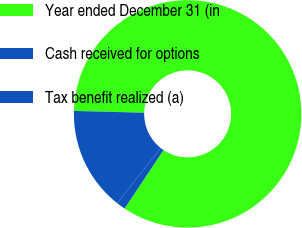<chart> <loc_0><loc_0><loc_500><loc_500><pie_chart><fcel>Year ended December 31 (in<fcel>Cash received for options<fcel>Tax benefit realized (a)<nl><fcel>83.93%<fcel>14.77%<fcel>1.29%<nl></chart> 